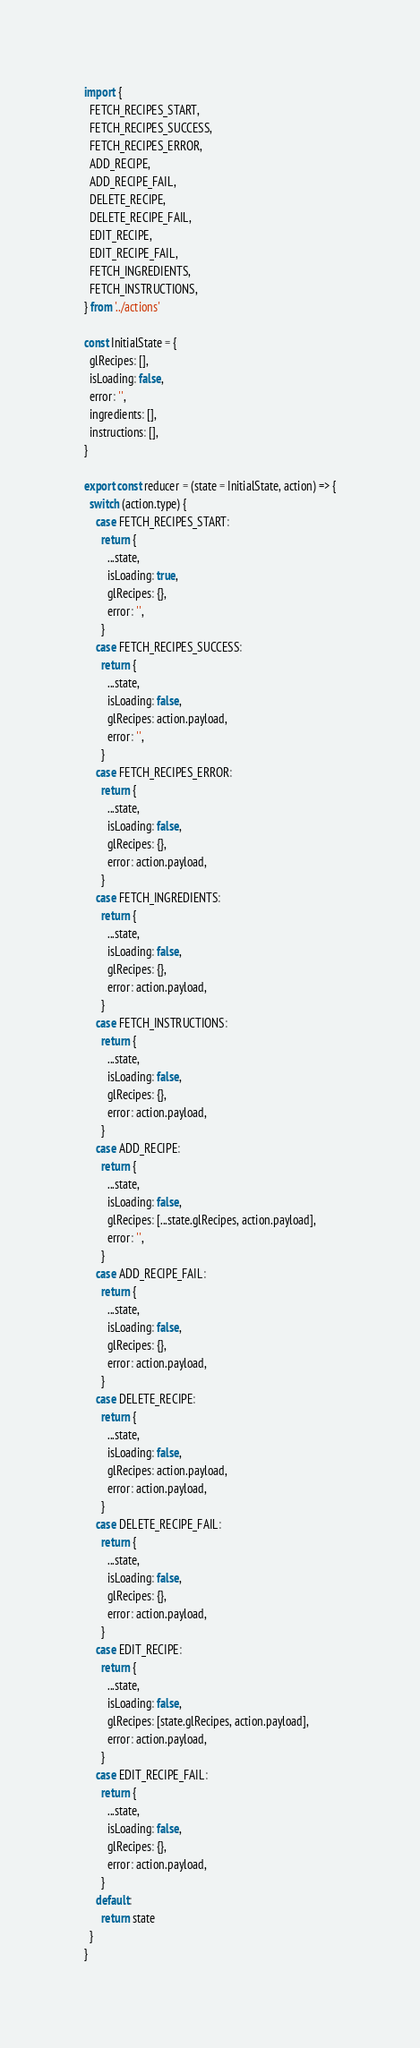<code> <loc_0><loc_0><loc_500><loc_500><_JavaScript_>import {
  FETCH_RECIPES_START,
  FETCH_RECIPES_SUCCESS,
  FETCH_RECIPES_ERROR,
  ADD_RECIPE,
  ADD_RECIPE_FAIL,
  DELETE_RECIPE,
  DELETE_RECIPE_FAIL,
  EDIT_RECIPE,
  EDIT_RECIPE_FAIL,
  FETCH_INGREDIENTS,
  FETCH_INSTRUCTIONS,
} from '../actions'

const InitialState = {
  glRecipes: [],
  isLoading: false,
  error: '',
  ingredients: [],
  instructions: [],
}

export const reducer = (state = InitialState, action) => {
  switch (action.type) {
    case FETCH_RECIPES_START:
      return {
        ...state,
        isLoading: true,
        glRecipes: {},
        error: '',
      }
    case FETCH_RECIPES_SUCCESS:
      return {
        ...state,
        isLoading: false,
        glRecipes: action.payload,
        error: '',
      }
    case FETCH_RECIPES_ERROR:
      return {
        ...state,
        isLoading: false,
        glRecipes: {},
        error: action.payload,
      }
    case FETCH_INGREDIENTS:
      return {
        ...state,
        isLoading: false,
        glRecipes: {},
        error: action.payload,
      }
    case FETCH_INSTRUCTIONS:
      return {
        ...state,
        isLoading: false,
        glRecipes: {},
        error: action.payload,
      }
    case ADD_RECIPE:
      return {
        ...state,
        isLoading: false,
        glRecipes: [...state.glRecipes, action.payload],
        error: '',
      }
    case ADD_RECIPE_FAIL:
      return {
        ...state,
        isLoading: false,
        glRecipes: {},
        error: action.payload,
      }
    case DELETE_RECIPE:
      return {
        ...state,
        isLoading: false,
        glRecipes: action.payload,
        error: action.payload,
      }
    case DELETE_RECIPE_FAIL:
      return {
        ...state,
        isLoading: false,
        glRecipes: {},
        error: action.payload,
      }
    case EDIT_RECIPE:
      return {
        ...state,
        isLoading: false,
        glRecipes: [state.glRecipes, action.payload],
        error: action.payload,
      }
    case EDIT_RECIPE_FAIL:
      return {
        ...state,
        isLoading: false,
        glRecipes: {},
        error: action.payload,
      }
    default:
      return state
  }
}
</code> 